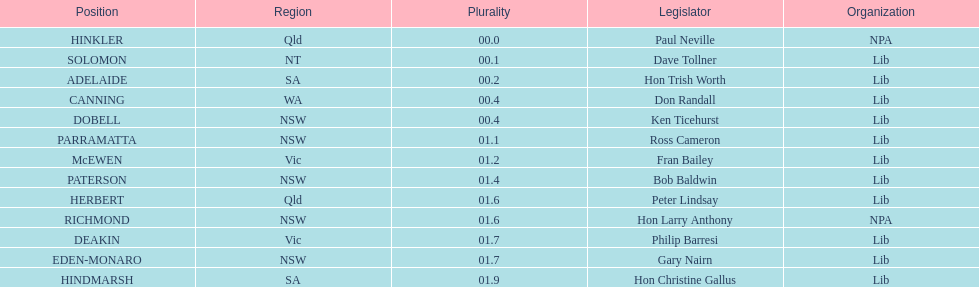What is the total of seats? 13. 